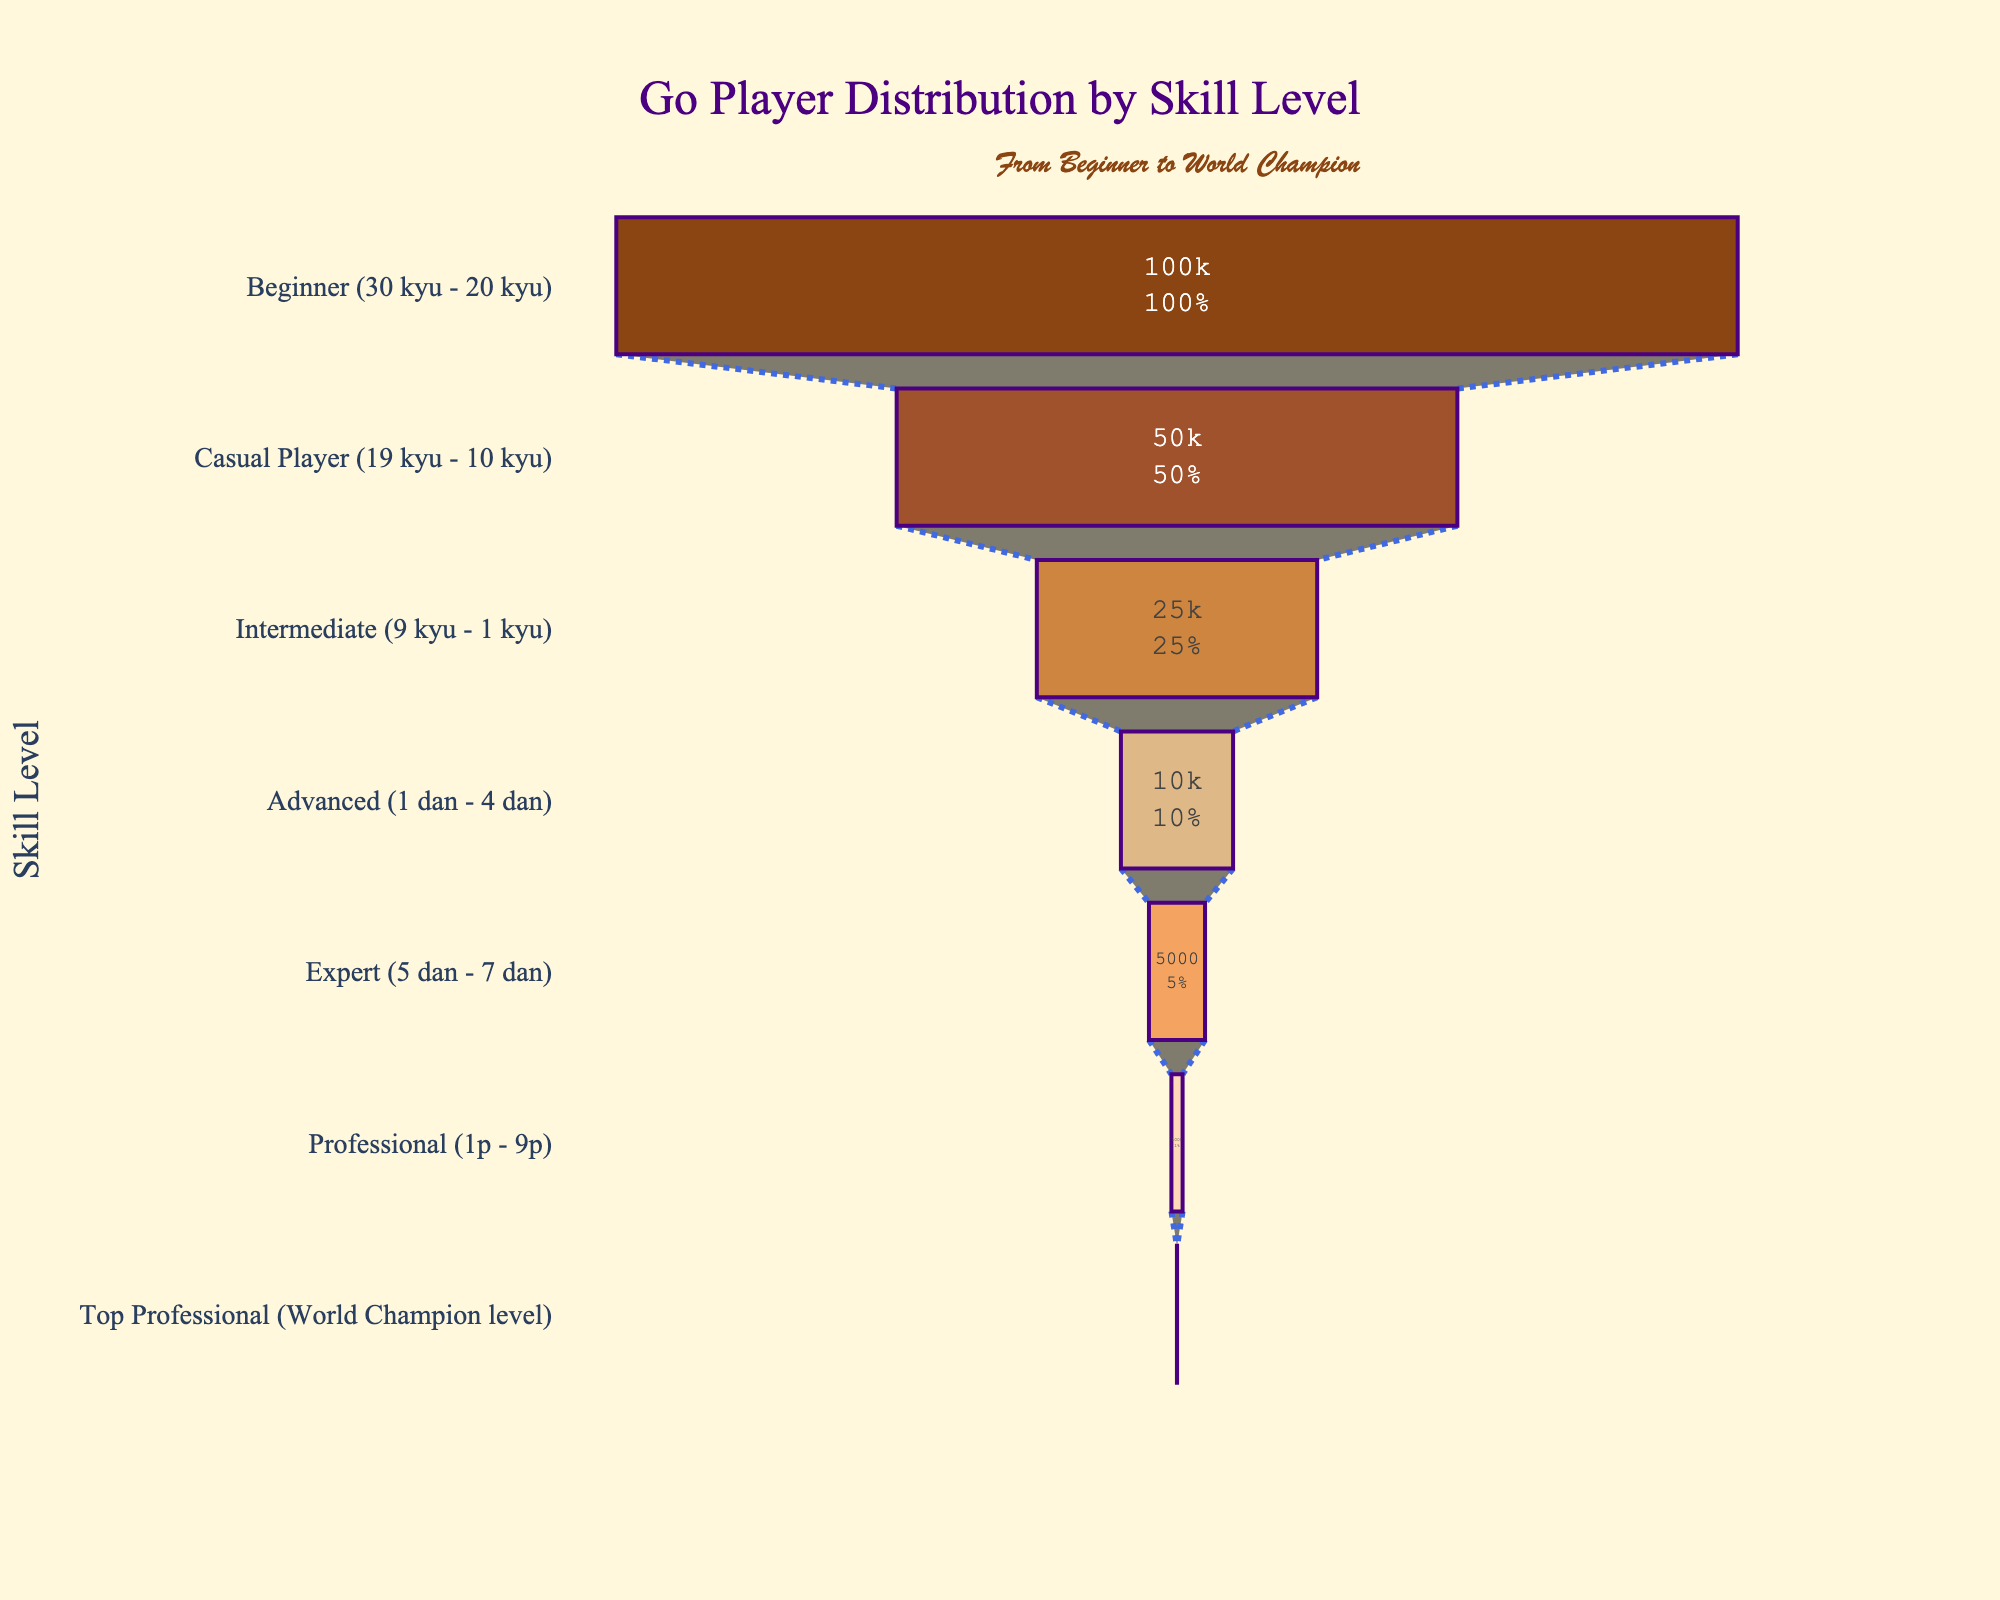What's the title of the chart? The title of the chart is located at the top in a larger font size. It provides a summary of what the chart is about.
Answer: Go Player Distribution by Skill Level How many players are at the Beginner level? The chart lists player counts alongside each skill level segment. Referring to the first segment indicates the number of players in that category.
Answer: 100,000 Which skill level has the fewest players? By observing the funnel segments and noting the player counts, the narrowest segment with the smallest number indicates the skill level with the fewest players.
Answer: Top Professional (World Champion level) What percentage of players are Advanced level or higher? To find this, sum the players from Advanced, Expert, Professional, and Top Professional levels, then divide by the total number of players, and multiply by 100. (10,000 + 5,000 + 1,000 + 10) / 191,010 ≈ 8.4%
Answer: 8.4% What's the difference in player count between Casual Players and Intermediate players? Subtract the number of Intermediate players from the number of Casual Players, referring to their respective segments. 50,000 - 25,000 = 25,000
Answer: 25,000 Which level has the largest drop in the number of players compared to the previous level? Calculate the drop in players between successive levels and identify the largest value. The drop is largest from Beginner to Casual Player: 100,000 - 50,000 = 50,000
Answer: Beginner to Casual Player What color represents the Intermediate level in the funnel chart? Observing the colors used for each segment, the Intermediate level is represented by the color that corresponds to its position.
Answer: Tan Brown What text information is displayed inside each segment of the funnel chart? The chart's segments contain both the number of players and the percentage of the total initial players.
Answer: Value and percent initial What is the total number of players represented in the chart? Sum the player counts from all levels as provided in the data. 100,000 + 50,000 + 25,000 + 10,000 + 5,000 + 1,000 + 10 = 191,010
Answer: 191,010 